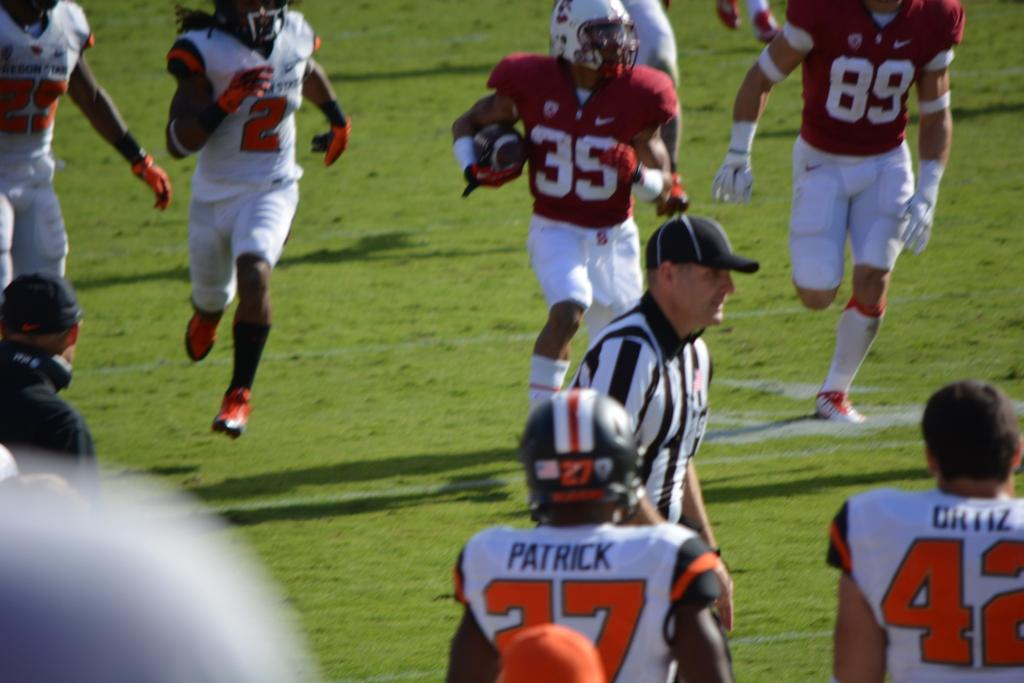What activity are the people engaged in within the image? People are playing a game. Can you describe the role of the person standing in the center? There is a referee standing in the center. Where is the ball located in relation to the referee? A person is holding the ball behind the referee. What type of watch is the referee wearing in the image? There is no watch visible on the referee in the image. 